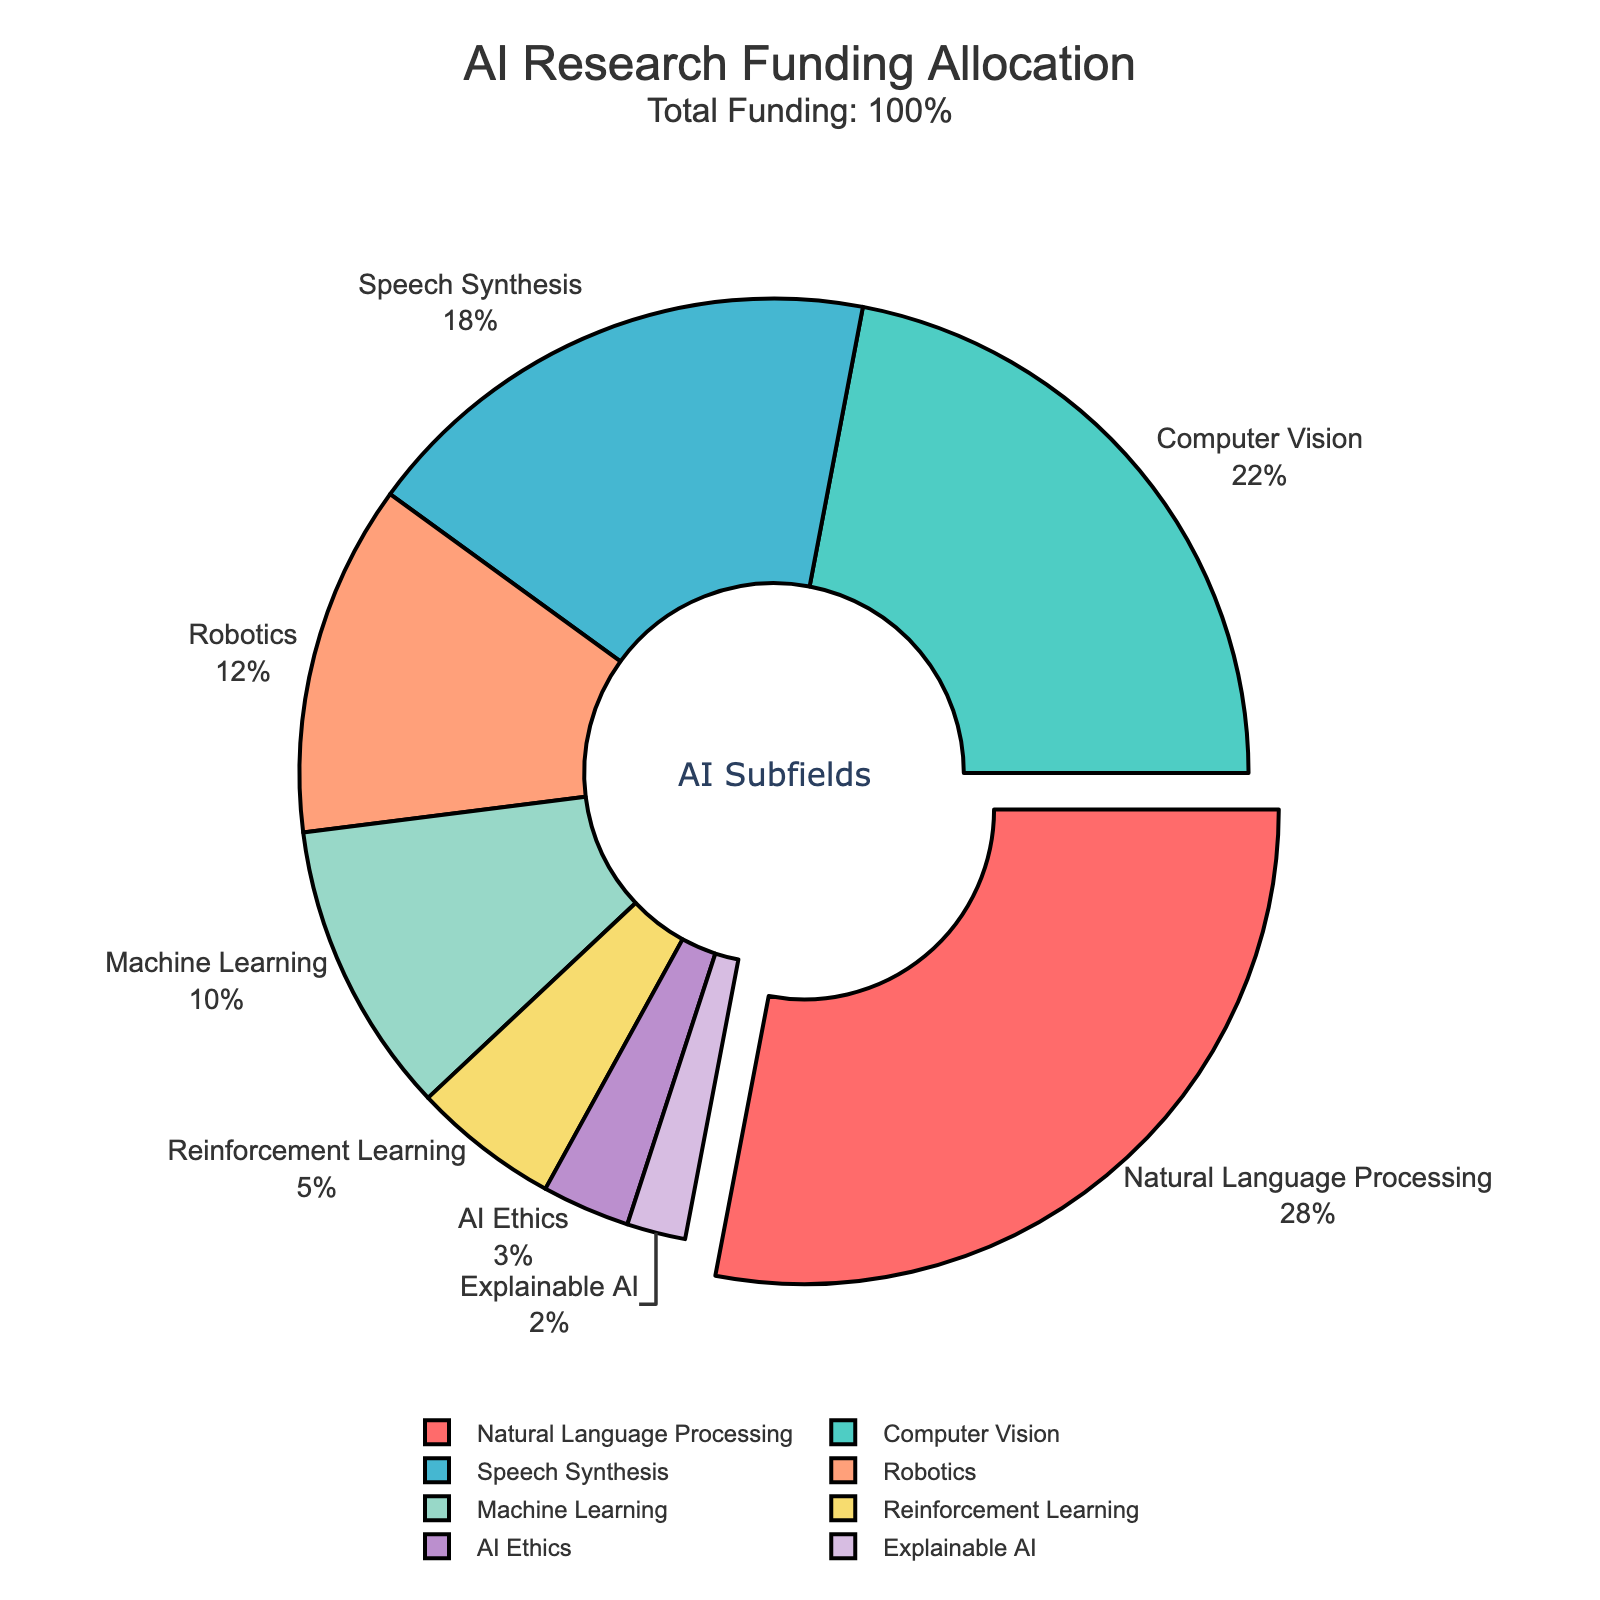Which subfield receives the highest percentage of funding? Looking at the plot, the slice representing "Natural Language Processing" is pulled out from the chart, indicating it has the highest percentage.
Answer: Natural Language Processing Which subfield receives the lowest percentage of funding? Observing the chart, the smallest slice belongs to "Explainable AI," indicating it receives the least funding.
Answer: Explainable AI How much more funding does Natural Language Processing get compared to AI Ethics? Natural Language Processing has 28%, and AI Ethics has 3%. The difference is 28% - 3% = 25%.
Answer: 25% What is the total percentage of funding received by Robotics and Machine Learning together? Robotics receives 12%, and Machine Learning receives 10%. Together, they receive 12% + 10% = 22%.
Answer: 22% Out of the total funding, what percentage is allocated to subfields other than Natural Language Processing and Computer Vision? Natural Language Processing and Computer Vision together account for 28% + 22% = 50%. The remaining funding is 100% - 50% = 50%.
Answer: 50% Which subfield receives more funding: Reinforcement Learning or AI Ethics? Comparing the slices, Reinforcement Learning has 5%, while AI Ethics has 3%. Therefore, Reinforcement Learning receives more funding.
Answer: Reinforcement Learning How much funding is allocated to the combination of subfields receiving less than 10% individually? The subfields AI Ethics (3%) and Explainable AI (2%) each receive less than 10%. Combined, they receive 3% + 2% = 5%.
Answer: 5% What visual feature helps to identify the subfield with the maximum funding? The slice representing "Natural Language Processing" is pulled out from the pie chart, visually indicating it has the maximum funding.
Answer: Pulled-out slice Which two subfields combined are closest in total funding to Natural Language Processing? NLP has 28%. Looking at pairs: (Computer Vision + Reinforcement Learning) equals 22% + 5% = 27%, which is the closest to 28%.
Answer: Computer Vision and Reinforcement Learning What is the combined percentage of funding for Speech Synthesis, Robotics, and Explainable AI? These subfields receive: Speech Synthesis 18%, Robotics 12%, and Explainable AI 2%. Summing these gives 18% + 12% + 2% = 32%.
Answer: 32% 